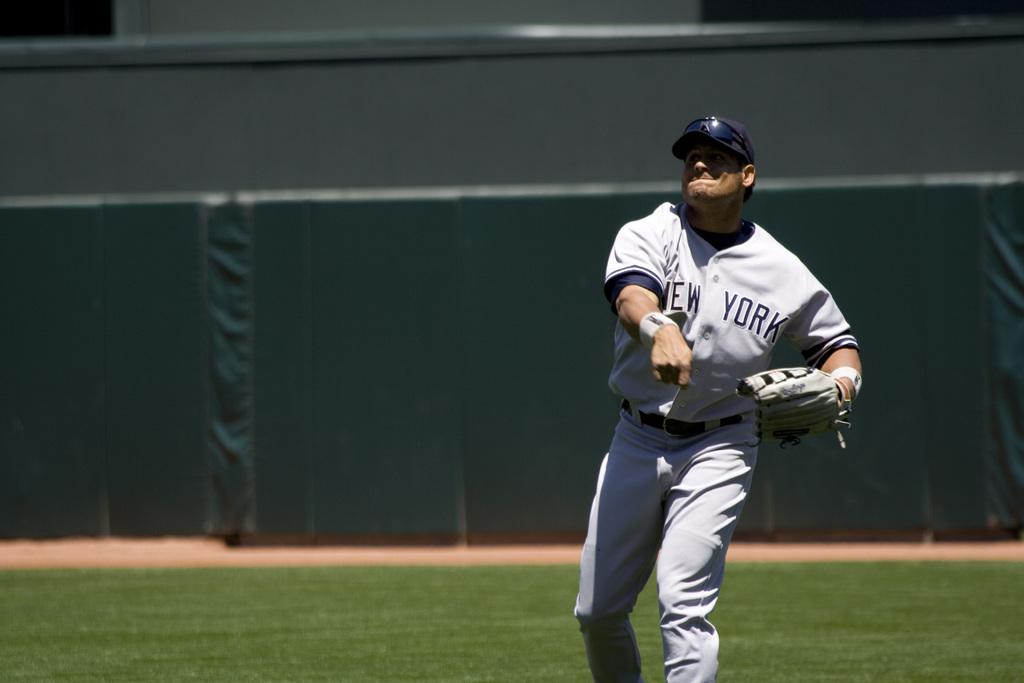<image>
Offer a succinct explanation of the picture presented. A man throwing a baseball wearing a New York jersey. 